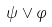Convert formula to latex. <formula><loc_0><loc_0><loc_500><loc_500>\psi \vee \varphi</formula> 